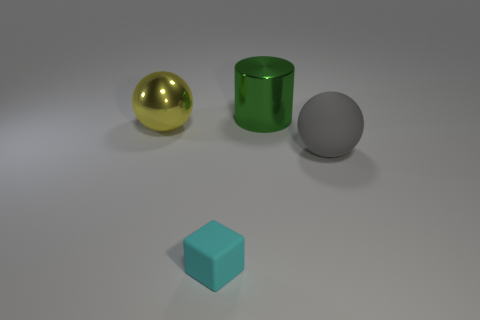Add 2 small cyan cubes. How many objects exist? 6 Subtract all cubes. How many objects are left? 3 Subtract all big yellow shiny cylinders. Subtract all spheres. How many objects are left? 2 Add 1 cylinders. How many cylinders are left? 2 Add 4 large green metal objects. How many large green metal objects exist? 5 Subtract 1 cyan blocks. How many objects are left? 3 